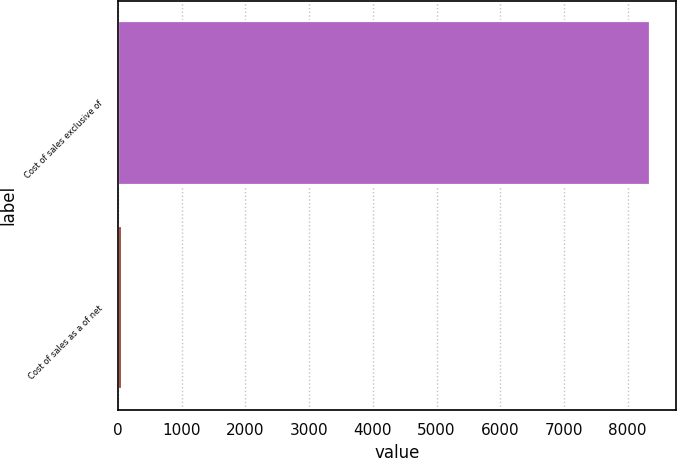Convert chart. <chart><loc_0><loc_0><loc_500><loc_500><bar_chart><fcel>Cost of sales exclusive of<fcel>Cost of sales as a of net<nl><fcel>8348<fcel>56.4<nl></chart> 